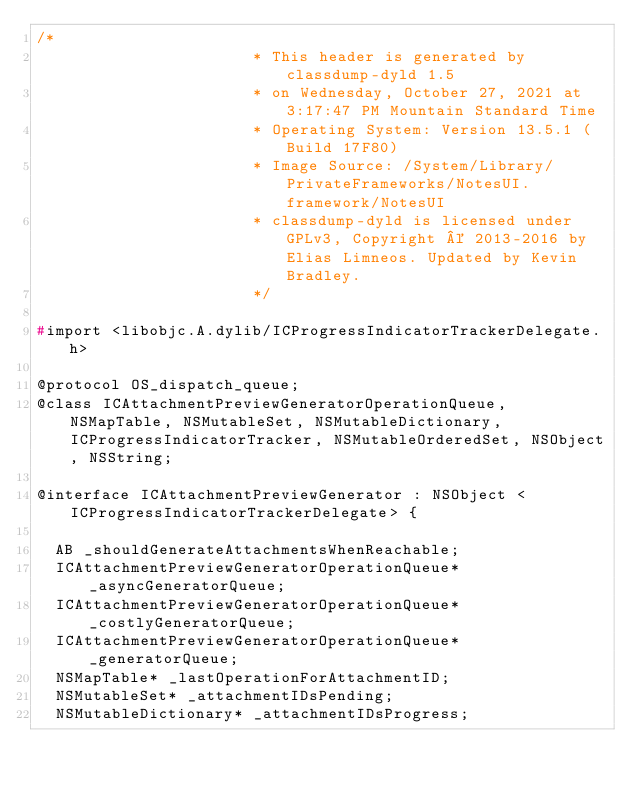Convert code to text. <code><loc_0><loc_0><loc_500><loc_500><_C_>/*
                       * This header is generated by classdump-dyld 1.5
                       * on Wednesday, October 27, 2021 at 3:17:47 PM Mountain Standard Time
                       * Operating System: Version 13.5.1 (Build 17F80)
                       * Image Source: /System/Library/PrivateFrameworks/NotesUI.framework/NotesUI
                       * classdump-dyld is licensed under GPLv3, Copyright © 2013-2016 by Elias Limneos. Updated by Kevin Bradley.
                       */

#import <libobjc.A.dylib/ICProgressIndicatorTrackerDelegate.h>

@protocol OS_dispatch_queue;
@class ICAttachmentPreviewGeneratorOperationQueue, NSMapTable, NSMutableSet, NSMutableDictionary, ICProgressIndicatorTracker, NSMutableOrderedSet, NSObject, NSString;

@interface ICAttachmentPreviewGenerator : NSObject <ICProgressIndicatorTrackerDelegate> {

	AB _shouldGenerateAttachmentsWhenReachable;
	ICAttachmentPreviewGeneratorOperationQueue* _asyncGeneratorQueue;
	ICAttachmentPreviewGeneratorOperationQueue* _costlyGeneratorQueue;
	ICAttachmentPreviewGeneratorOperationQueue* _generatorQueue;
	NSMapTable* _lastOperationForAttachmentID;
	NSMutableSet* _attachmentIDsPending;
	NSMutableDictionary* _attachmentIDsProgress;</code> 